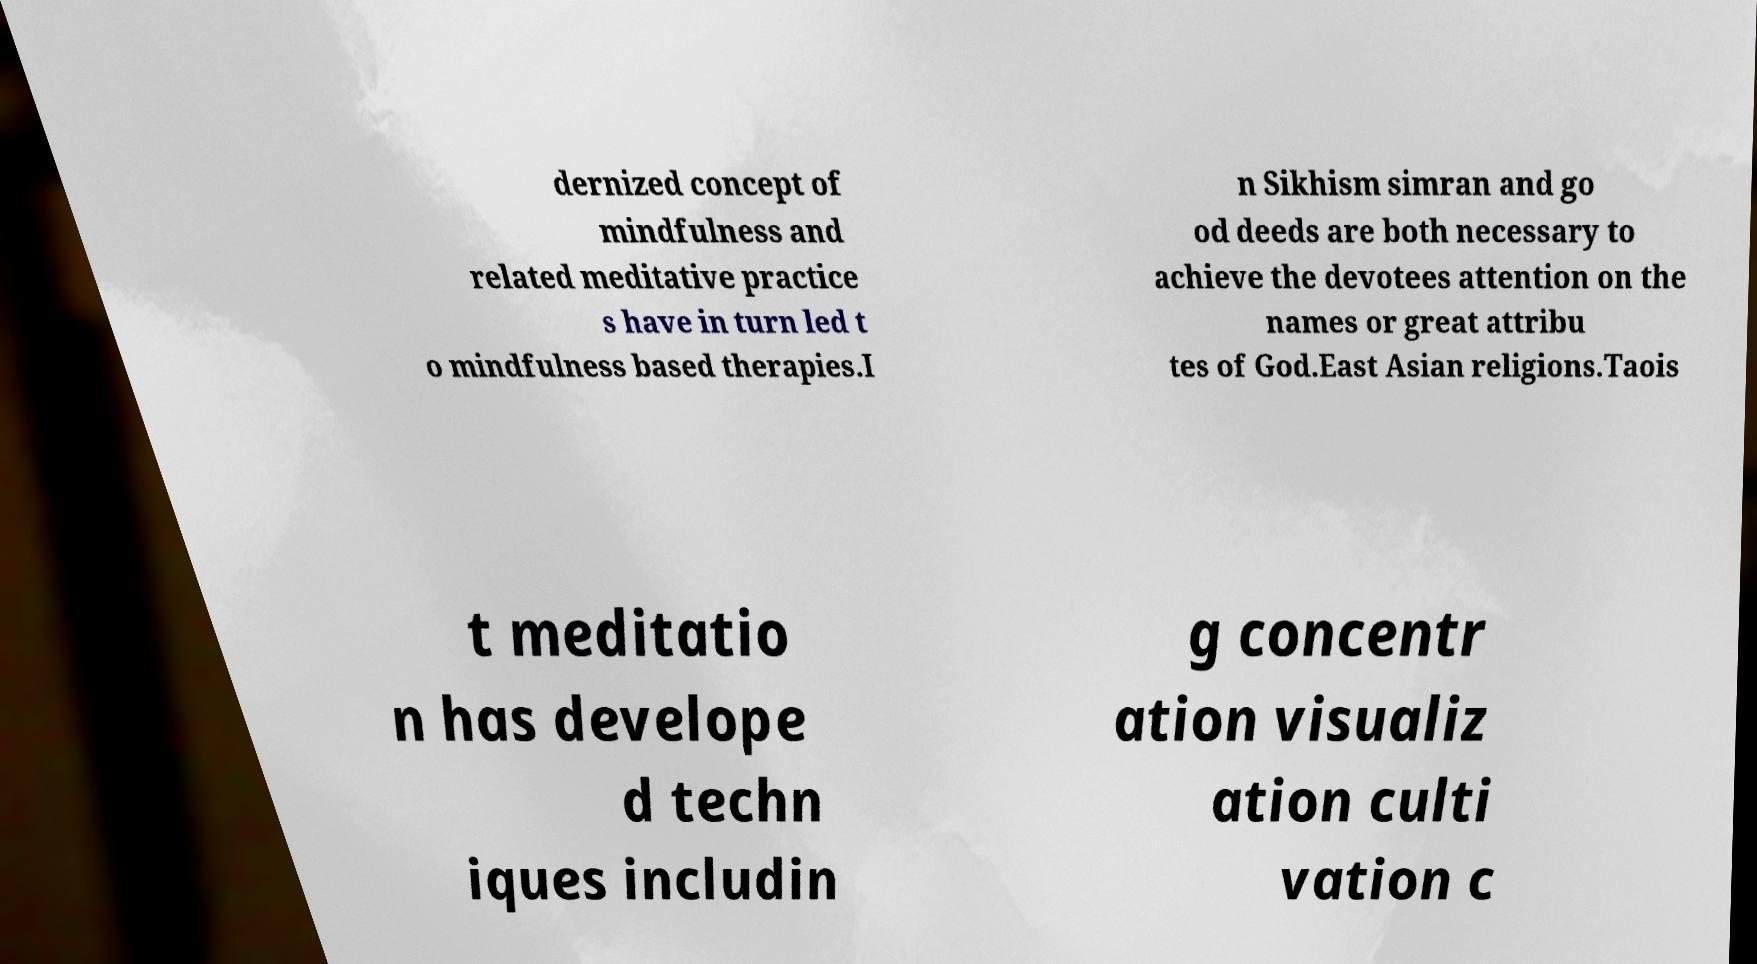Please identify and transcribe the text found in this image. dernized concept of mindfulness and related meditative practice s have in turn led t o mindfulness based therapies.I n Sikhism simran and go od deeds are both necessary to achieve the devotees attention on the names or great attribu tes of God.East Asian religions.Taois t meditatio n has develope d techn iques includin g concentr ation visualiz ation culti vation c 